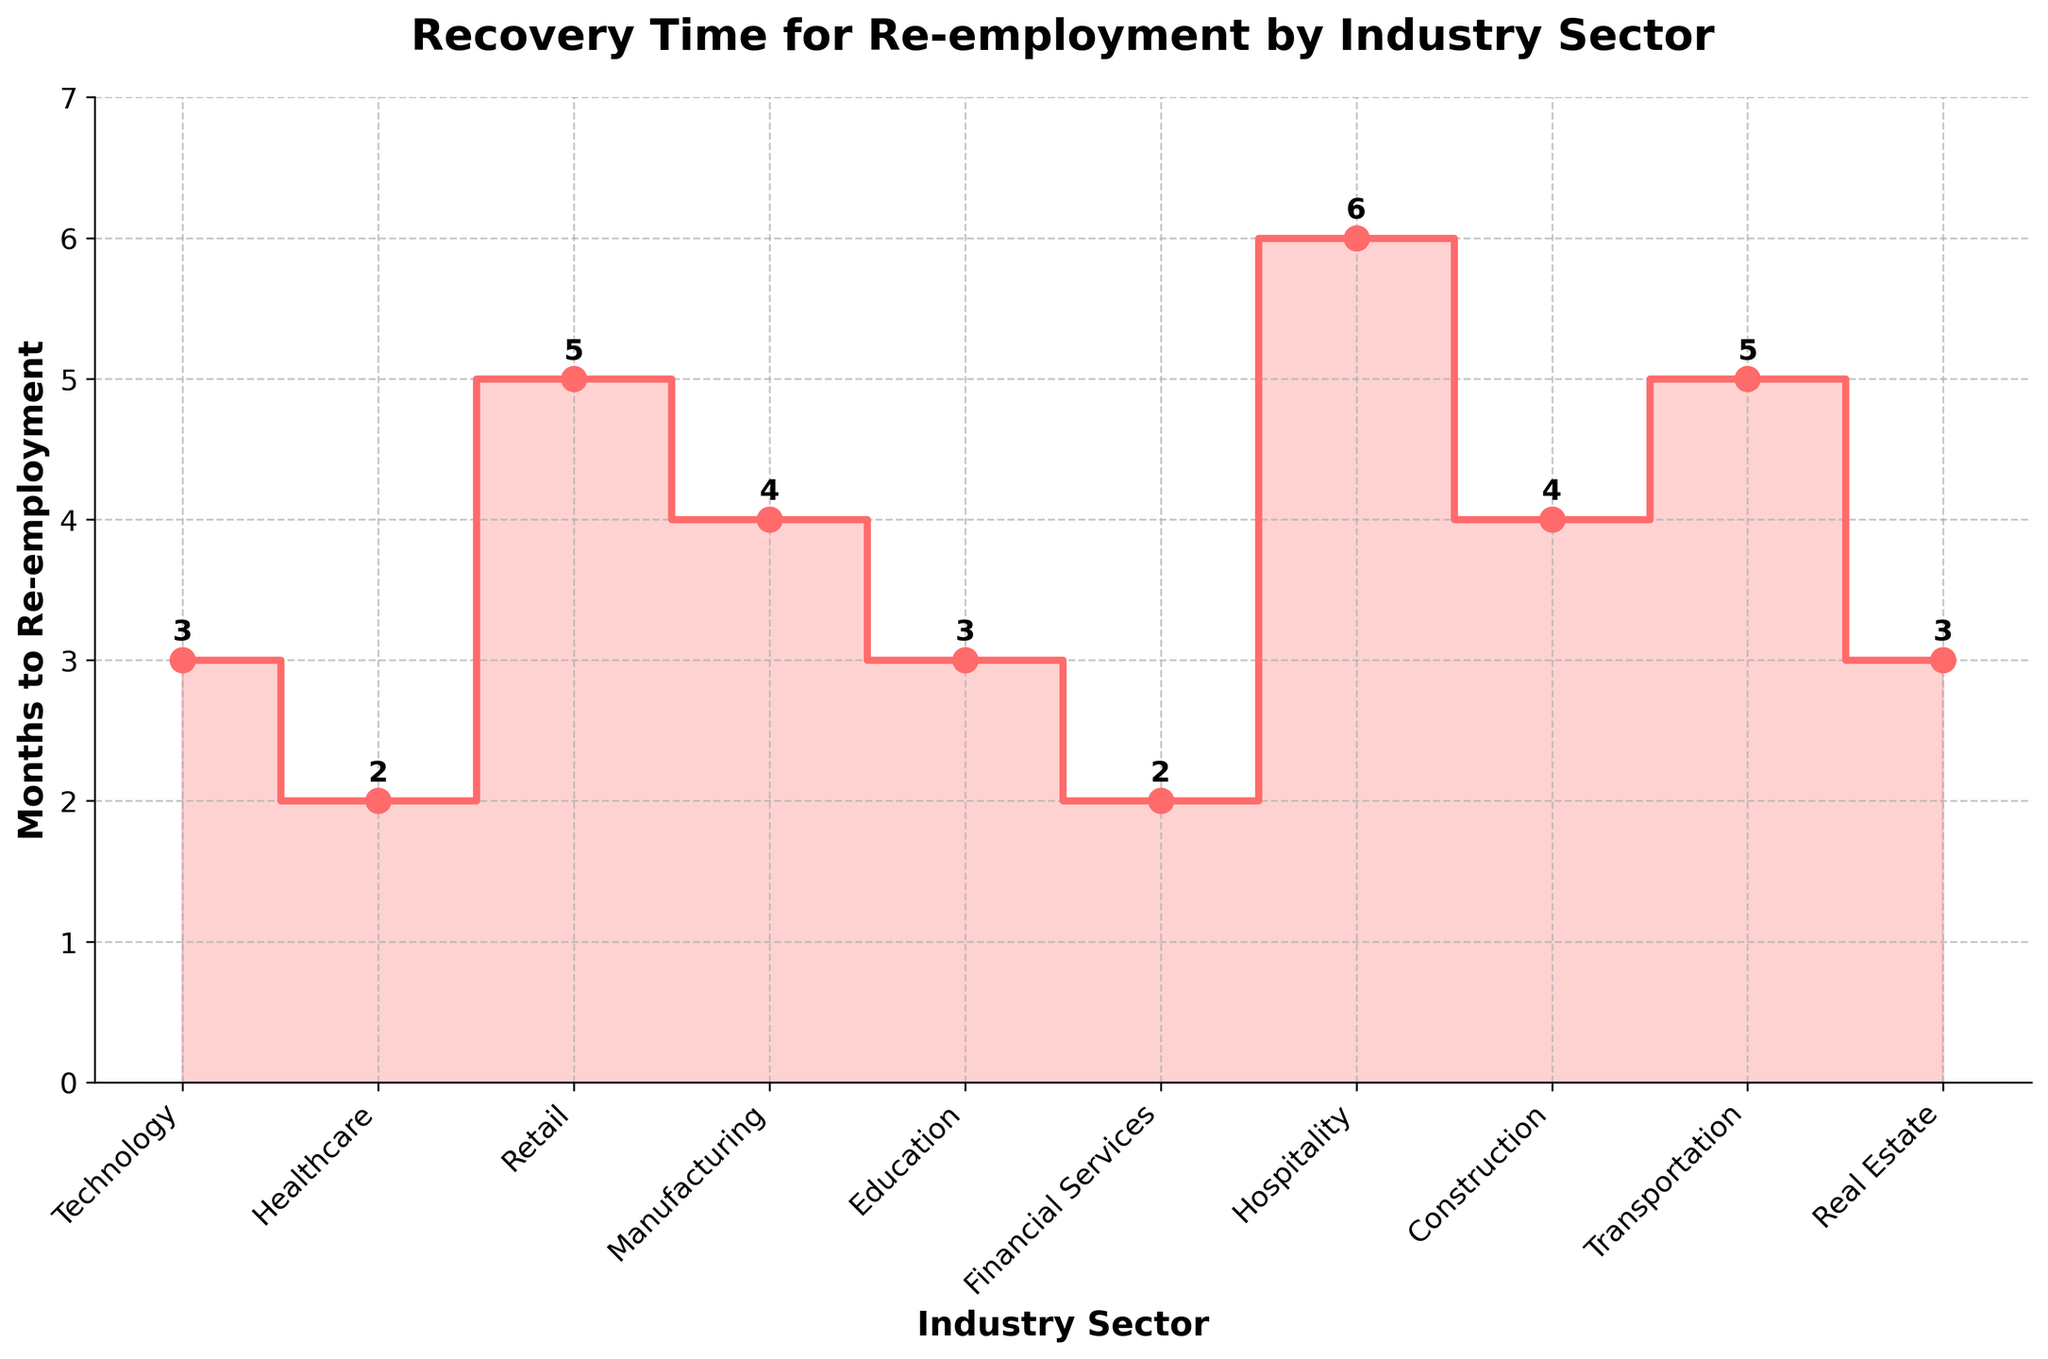What is the title of the figure? The title of a plot is usually placed at the top and is bold. In this plot, it states "Recovery Time for Re-employment by Industry Sector", which provides a clear summary of what the data represents.
Answer: Recovery Time for Re-employment by Industry Sector Which industry sector has the shortest re-employment time? By examining the y-axis values corresponding to the lowest point, we see that Healthcare and Financial Services has the shortest re-employment times, both at 2 months.
Answer: Healthcare and Financial Services Which industry sector has the longest re-employment time, and what is the value? Look at the highest point on the y-axis and find the corresponding industry on the x-axis. Hospitality has the longest re-employment time at 6 months.
Answer: Hospitality, 6 months What is the general trend of the plot? The plot has a staggered appearance with ups and downs, indicating variability in re-employment times across industries. It visually represents that re-employment times differ significantly by industry.
Answer: Variable re-employment times How many months does it take on average for re-employment across all the industries? To find the average, you sum all the months and divide by the number of industries: (3 + 2 + 5 + 4 + 3 + 2 + 6 + 4 + 5 + 3)/10 = 3.7 months.
Answer: 3.7 months What is the difference in re-employment time between Technology and Retail? By identifying the values for Technology (3 months) and Retail (5 months) from the plot, calculate the difference: 5 - 3 = 2 months.
Answer: 2 months Which industry sectors have re-employment times that are equal to 3 months? Identify the points on the y-axis at 3 months and find the corresponding industries on the x-axis: Technology, Education, and Real Estate all have a re-employment time of 3 months.
Answer: Technology, Education, Real Estate How does the re-employment time for Education compare to that of Manufacturing? Find the values for each industry: Education (3 months) and Manufacturing (4 months). Since 3 is less than 4, Education has a shorter re-employment time.
Answer: Education is shorter What is the median re-employment time for the given industries? To determine the median, list the months, sort them, and find the middle value. The sorted values are [2, 2, 3, 3, 3, 4, 4, 5, 5, 6]. The median is the average of the middle two values (3 and 4), which is (3+4)/2 = 3.5 months.
Answer: 3.5 months What percentage of industries have re-employment times of 4 months or more? Count the number of industries with 4 months or more (Manufacturing, Construction, Transportation, Retail, Hospitality) which is 5 out of 10. Calculate the percentage: (5/10)*100 = 50%.
Answer: 50% 